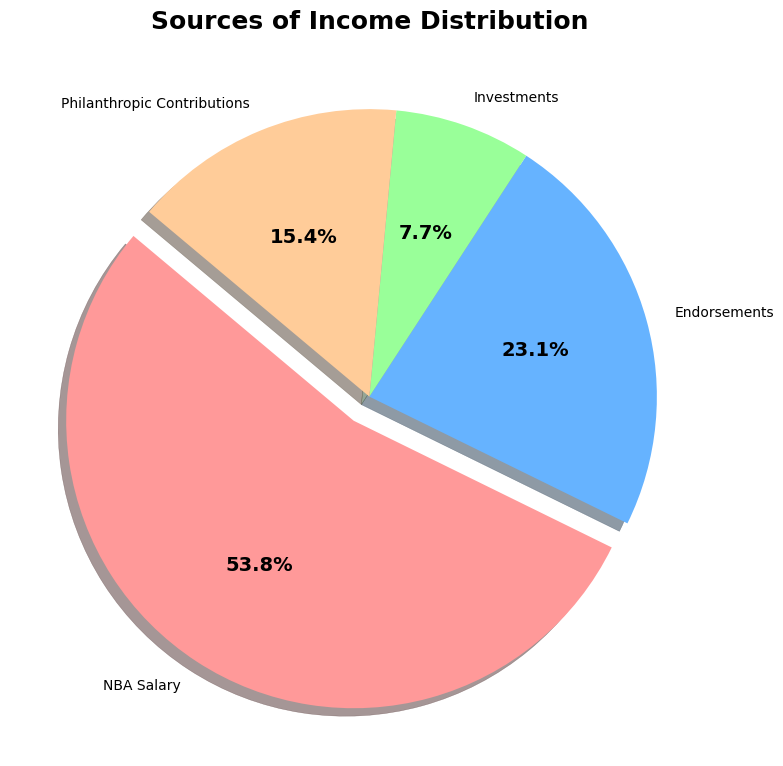What percentage of income is attributed to NBA Salary? Look at the section labeled "NBA Salary" on the pie chart. The percentage should be displayed within or near that section.
Answer: 53.8% Which is contributing more to the income, Endorsements or Philanthropic Contributions? Compare the slices on the pie chart labeled "Endorsements" and “Philanthropic Contributions.” Determine which has the larger percentage.
Answer: Endorsements What is the combined percentage of income from Investments and Philanthropic Contributions? Locate the percentages for “Investments” and “Philanthropic Contributions” on the pie chart. Add these percentages together.
Answer: 23.1% Of the sources of income, which one has the smallest share? Identify the smallest slice of the pie chart by visually comparing the sizes of all slices.
Answer: Investments What is the difference in income percentage between NBA Salary and Endorsements? Find the percentages of NBA Salary and Endorsements on the pie chart. Subtract the Endorsements percentage from the NBA Salary percentage.
Answer: 30.7% What income source is represented by the red color on the pie chart? Look at the pie chart and identify the income source that is represented by the red-colored slice.
Answer: NBA Salary How much percentage more is NBA Salary compared to Investments? Find the percentage of NBA Salary and Investments on the pie chart. Subtract the Investments percentage from the NBA Salary percentage.
Answer: 46.2% Arrange the income sources in descending order of their percentage contributions. Identify the percentages for all income sources on the pie chart and then list them starting from the largest to the smallest.
Answer: NBA Salary, Endorsements, Philanthropic Contributions, Investments If the total income is $65,000,000, what is the income generated from Endorsements? First, identify the percentage contribution of Endorsements from the pie chart. Then calculate 23.1% of $65,000,000.
Answer: $15,000,000 